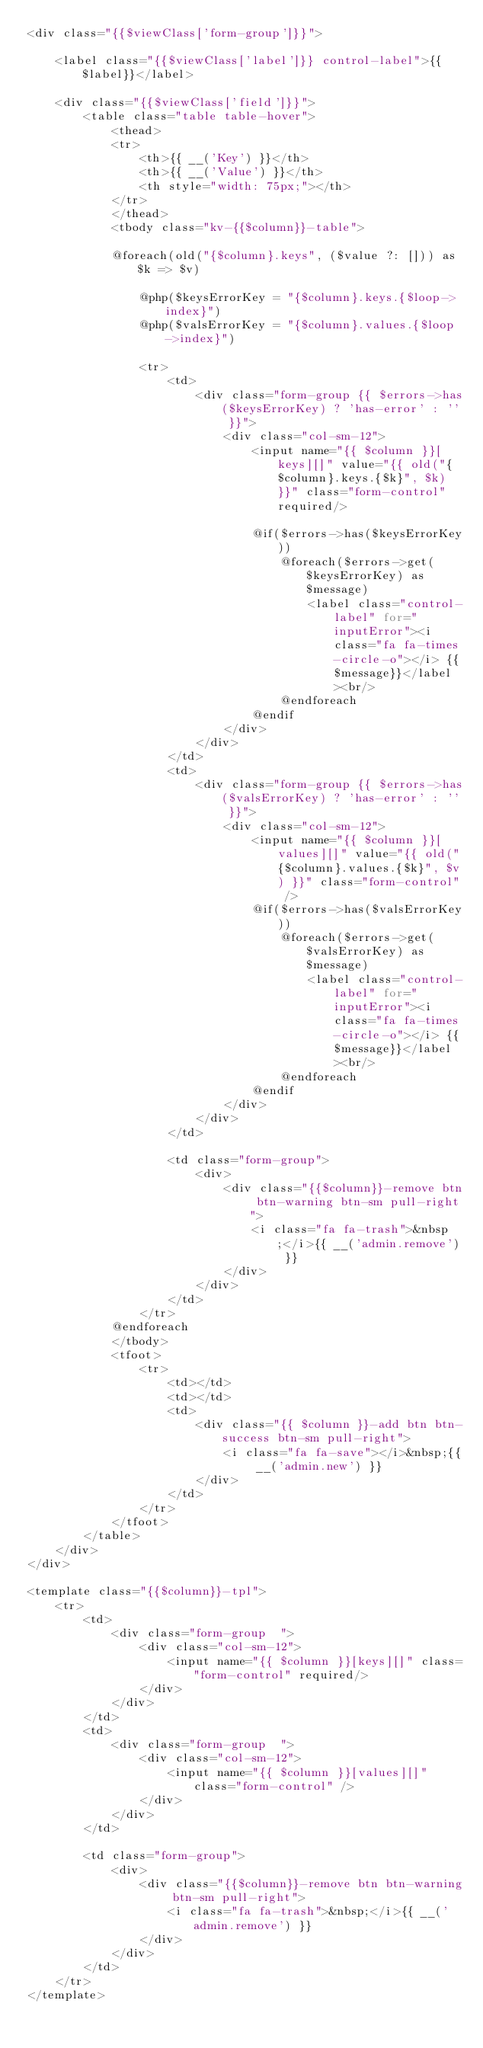<code> <loc_0><loc_0><loc_500><loc_500><_PHP_><div class="{{$viewClass['form-group']}}">

    <label class="{{$viewClass['label']}} control-label">{{$label}}</label>

    <div class="{{$viewClass['field']}}">
        <table class="table table-hover">
            <thead>
            <tr>
                <th>{{ __('Key') }}</th>
                <th>{{ __('Value') }}</th>
                <th style="width: 75px;"></th>
            </tr>
            </thead>
            <tbody class="kv-{{$column}}-table">

            @foreach(old("{$column}.keys", ($value ?: [])) as $k => $v)

                @php($keysErrorKey = "{$column}.keys.{$loop->index}")
                @php($valsErrorKey = "{$column}.values.{$loop->index}")

                <tr>
                    <td>
                        <div class="form-group {{ $errors->has($keysErrorKey) ? 'has-error' : '' }}">
                            <div class="col-sm-12">
                                <input name="{{ $column }}[keys][]" value="{{ old("{$column}.keys.{$k}", $k) }}" class="form-control" required/>

                                @if($errors->has($keysErrorKey))
                                    @foreach($errors->get($keysErrorKey) as $message)
                                        <label class="control-label" for="inputError"><i class="fa fa-times-circle-o"></i> {{$message}}</label><br/>
                                    @endforeach
                                @endif
                            </div>
                        </div>
                    </td>
                    <td>
                        <div class="form-group {{ $errors->has($valsErrorKey) ? 'has-error' : '' }}">
                            <div class="col-sm-12">
                                <input name="{{ $column }}[values][]" value="{{ old("{$column}.values.{$k}", $v) }}" class="form-control" />
                                @if($errors->has($valsErrorKey))
                                    @foreach($errors->get($valsErrorKey) as $message)
                                        <label class="control-label" for="inputError"><i class="fa fa-times-circle-o"></i> {{$message}}</label><br/>
                                    @endforeach
                                @endif
                            </div>
                        </div>
                    </td>

                    <td class="form-group">
                        <div>
                            <div class="{{$column}}-remove btn btn-warning btn-sm pull-right">
                                <i class="fa fa-trash">&nbsp;</i>{{ __('admin.remove') }}
                            </div>
                        </div>
                    </td>
                </tr>
            @endforeach
            </tbody>
            <tfoot>
                <tr>
                    <td></td>
                    <td></td>
                    <td>
                        <div class="{{ $column }}-add btn btn-success btn-sm pull-right">
                            <i class="fa fa-save"></i>&nbsp;{{ __('admin.new') }}
                        </div>
                    </td>
                </tr>
            </tfoot>
        </table>
    </div>
</div>

<template class="{{$column}}-tpl">
    <tr>
        <td>
            <div class="form-group  ">
                <div class="col-sm-12">
                    <input name="{{ $column }}[keys][]" class="form-control" required/>
                </div>
            </div>
        </td>
        <td>
            <div class="form-group  ">
                <div class="col-sm-12">
                    <input name="{{ $column }}[values][]" class="form-control" />
                </div>
            </div>
        </td>

        <td class="form-group">
            <div>
                <div class="{{$column}}-remove btn btn-warning btn-sm pull-right">
                    <i class="fa fa-trash">&nbsp;</i>{{ __('admin.remove') }}
                </div>
            </div>
        </td>
    </tr>
</template></code> 